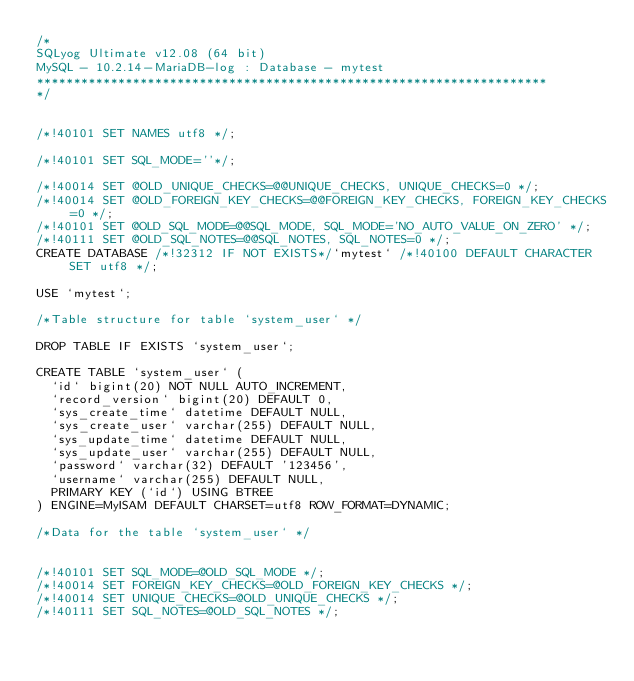Convert code to text. <code><loc_0><loc_0><loc_500><loc_500><_SQL_>/*
SQLyog Ultimate v12.08 (64 bit)
MySQL - 10.2.14-MariaDB-log : Database - mytest
*********************************************************************
*/


/*!40101 SET NAMES utf8 */;

/*!40101 SET SQL_MODE=''*/;

/*!40014 SET @OLD_UNIQUE_CHECKS=@@UNIQUE_CHECKS, UNIQUE_CHECKS=0 */;
/*!40014 SET @OLD_FOREIGN_KEY_CHECKS=@@FOREIGN_KEY_CHECKS, FOREIGN_KEY_CHECKS=0 */;
/*!40101 SET @OLD_SQL_MODE=@@SQL_MODE, SQL_MODE='NO_AUTO_VALUE_ON_ZERO' */;
/*!40111 SET @OLD_SQL_NOTES=@@SQL_NOTES, SQL_NOTES=0 */;
CREATE DATABASE /*!32312 IF NOT EXISTS*/`mytest` /*!40100 DEFAULT CHARACTER SET utf8 */;

USE `mytest`;

/*Table structure for table `system_user` */

DROP TABLE IF EXISTS `system_user`;

CREATE TABLE `system_user` (
  `id` bigint(20) NOT NULL AUTO_INCREMENT,
  `record_version` bigint(20) DEFAULT 0,
  `sys_create_time` datetime DEFAULT NULL,
  `sys_create_user` varchar(255) DEFAULT NULL,
  `sys_update_time` datetime DEFAULT NULL,
  `sys_update_user` varchar(255) DEFAULT NULL,
  `password` varchar(32) DEFAULT '123456',
  `username` varchar(255) DEFAULT NULL,
  PRIMARY KEY (`id`) USING BTREE
) ENGINE=MyISAM DEFAULT CHARSET=utf8 ROW_FORMAT=DYNAMIC;

/*Data for the table `system_user` */


/*!40101 SET SQL_MODE=@OLD_SQL_MODE */;
/*!40014 SET FOREIGN_KEY_CHECKS=@OLD_FOREIGN_KEY_CHECKS */;
/*!40014 SET UNIQUE_CHECKS=@OLD_UNIQUE_CHECKS */;
/*!40111 SET SQL_NOTES=@OLD_SQL_NOTES */;
</code> 